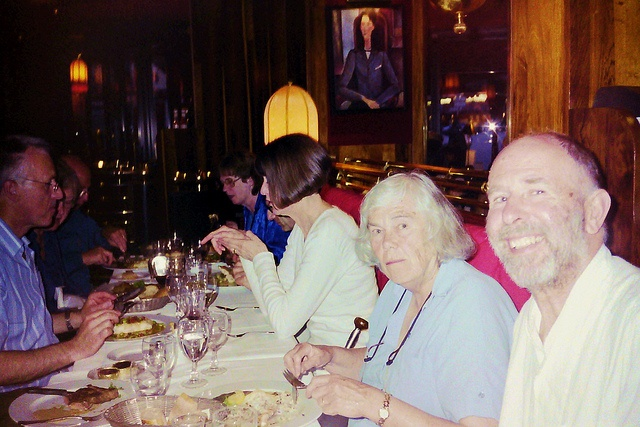Describe the objects in this image and their specific colors. I can see people in black, lightgray, tan, and lightblue tones, people in black, lightgray, darkgray, and tan tones, dining table in black, darkgray, beige, tan, and gray tones, people in black, lightgray, beige, and tan tones, and people in black, maroon, purple, and brown tones in this image. 